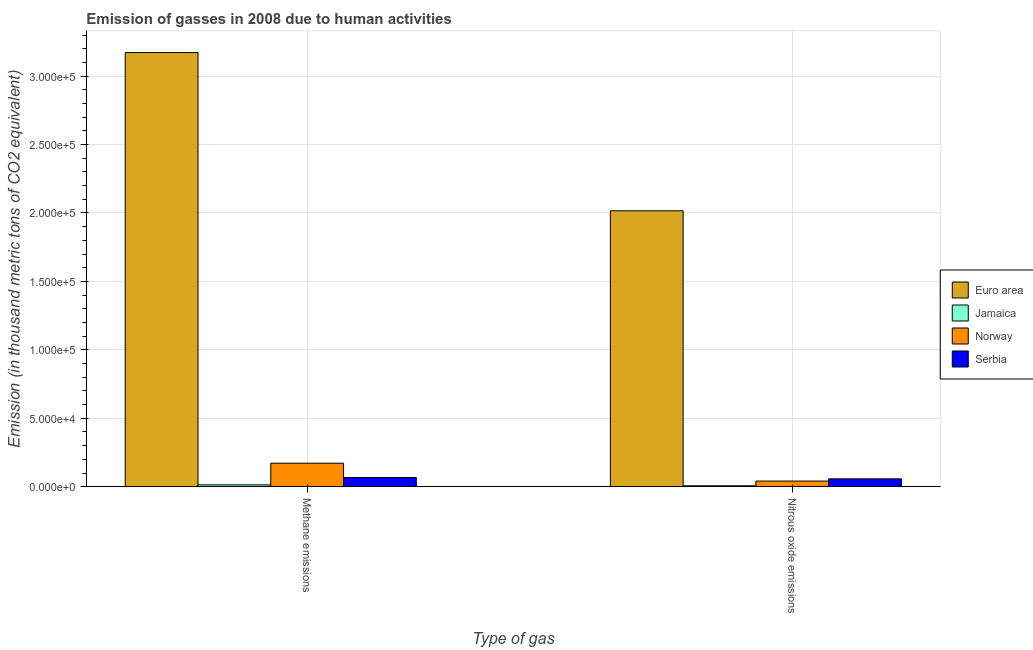Are the number of bars on each tick of the X-axis equal?
Give a very brief answer. Yes. How many bars are there on the 1st tick from the left?
Your answer should be very brief. 4. What is the label of the 2nd group of bars from the left?
Your answer should be very brief. Nitrous oxide emissions. What is the amount of nitrous oxide emissions in Jamaica?
Offer a terse response. 666.6. Across all countries, what is the maximum amount of nitrous oxide emissions?
Your answer should be very brief. 2.02e+05. Across all countries, what is the minimum amount of methane emissions?
Offer a very short reply. 1330.9. In which country was the amount of nitrous oxide emissions maximum?
Your response must be concise. Euro area. In which country was the amount of nitrous oxide emissions minimum?
Your answer should be very brief. Jamaica. What is the total amount of methane emissions in the graph?
Your answer should be compact. 3.42e+05. What is the difference between the amount of methane emissions in Jamaica and that in Serbia?
Your answer should be very brief. -5395.5. What is the difference between the amount of methane emissions in Jamaica and the amount of nitrous oxide emissions in Norway?
Provide a short and direct response. -2771.8. What is the average amount of methane emissions per country?
Offer a very short reply. 8.56e+04. What is the difference between the amount of nitrous oxide emissions and amount of methane emissions in Norway?
Provide a short and direct response. -1.31e+04. In how many countries, is the amount of methane emissions greater than 290000 thousand metric tons?
Ensure brevity in your answer.  1. What is the ratio of the amount of methane emissions in Euro area to that in Jamaica?
Offer a terse response. 238.38. How many bars are there?
Provide a succinct answer. 8. What is the difference between two consecutive major ticks on the Y-axis?
Provide a succinct answer. 5.00e+04. Does the graph contain any zero values?
Your response must be concise. No. Does the graph contain grids?
Make the answer very short. Yes. How are the legend labels stacked?
Your response must be concise. Vertical. What is the title of the graph?
Offer a very short reply. Emission of gasses in 2008 due to human activities. What is the label or title of the X-axis?
Your answer should be very brief. Type of gas. What is the label or title of the Y-axis?
Make the answer very short. Emission (in thousand metric tons of CO2 equivalent). What is the Emission (in thousand metric tons of CO2 equivalent) in Euro area in Methane emissions?
Make the answer very short. 3.17e+05. What is the Emission (in thousand metric tons of CO2 equivalent) in Jamaica in Methane emissions?
Make the answer very short. 1330.9. What is the Emission (in thousand metric tons of CO2 equivalent) of Norway in Methane emissions?
Your answer should be compact. 1.72e+04. What is the Emission (in thousand metric tons of CO2 equivalent) in Serbia in Methane emissions?
Provide a succinct answer. 6726.4. What is the Emission (in thousand metric tons of CO2 equivalent) of Euro area in Nitrous oxide emissions?
Provide a succinct answer. 2.02e+05. What is the Emission (in thousand metric tons of CO2 equivalent) in Jamaica in Nitrous oxide emissions?
Your answer should be very brief. 666.6. What is the Emission (in thousand metric tons of CO2 equivalent) in Norway in Nitrous oxide emissions?
Ensure brevity in your answer.  4102.7. What is the Emission (in thousand metric tons of CO2 equivalent) in Serbia in Nitrous oxide emissions?
Ensure brevity in your answer.  5711.8. Across all Type of gas, what is the maximum Emission (in thousand metric tons of CO2 equivalent) of Euro area?
Keep it short and to the point. 3.17e+05. Across all Type of gas, what is the maximum Emission (in thousand metric tons of CO2 equivalent) of Jamaica?
Keep it short and to the point. 1330.9. Across all Type of gas, what is the maximum Emission (in thousand metric tons of CO2 equivalent) in Norway?
Give a very brief answer. 1.72e+04. Across all Type of gas, what is the maximum Emission (in thousand metric tons of CO2 equivalent) in Serbia?
Offer a terse response. 6726.4. Across all Type of gas, what is the minimum Emission (in thousand metric tons of CO2 equivalent) in Euro area?
Offer a terse response. 2.02e+05. Across all Type of gas, what is the minimum Emission (in thousand metric tons of CO2 equivalent) in Jamaica?
Your response must be concise. 666.6. Across all Type of gas, what is the minimum Emission (in thousand metric tons of CO2 equivalent) in Norway?
Provide a succinct answer. 4102.7. Across all Type of gas, what is the minimum Emission (in thousand metric tons of CO2 equivalent) of Serbia?
Offer a very short reply. 5711.8. What is the total Emission (in thousand metric tons of CO2 equivalent) in Euro area in the graph?
Offer a terse response. 5.19e+05. What is the total Emission (in thousand metric tons of CO2 equivalent) in Jamaica in the graph?
Your answer should be compact. 1997.5. What is the total Emission (in thousand metric tons of CO2 equivalent) of Norway in the graph?
Provide a succinct answer. 2.13e+04. What is the total Emission (in thousand metric tons of CO2 equivalent) of Serbia in the graph?
Offer a terse response. 1.24e+04. What is the difference between the Emission (in thousand metric tons of CO2 equivalent) of Euro area in Methane emissions and that in Nitrous oxide emissions?
Offer a terse response. 1.16e+05. What is the difference between the Emission (in thousand metric tons of CO2 equivalent) in Jamaica in Methane emissions and that in Nitrous oxide emissions?
Your answer should be compact. 664.3. What is the difference between the Emission (in thousand metric tons of CO2 equivalent) in Norway in Methane emissions and that in Nitrous oxide emissions?
Provide a succinct answer. 1.31e+04. What is the difference between the Emission (in thousand metric tons of CO2 equivalent) in Serbia in Methane emissions and that in Nitrous oxide emissions?
Your answer should be very brief. 1014.6. What is the difference between the Emission (in thousand metric tons of CO2 equivalent) in Euro area in Methane emissions and the Emission (in thousand metric tons of CO2 equivalent) in Jamaica in Nitrous oxide emissions?
Offer a very short reply. 3.17e+05. What is the difference between the Emission (in thousand metric tons of CO2 equivalent) of Euro area in Methane emissions and the Emission (in thousand metric tons of CO2 equivalent) of Norway in Nitrous oxide emissions?
Ensure brevity in your answer.  3.13e+05. What is the difference between the Emission (in thousand metric tons of CO2 equivalent) of Euro area in Methane emissions and the Emission (in thousand metric tons of CO2 equivalent) of Serbia in Nitrous oxide emissions?
Make the answer very short. 3.12e+05. What is the difference between the Emission (in thousand metric tons of CO2 equivalent) in Jamaica in Methane emissions and the Emission (in thousand metric tons of CO2 equivalent) in Norway in Nitrous oxide emissions?
Give a very brief answer. -2771.8. What is the difference between the Emission (in thousand metric tons of CO2 equivalent) in Jamaica in Methane emissions and the Emission (in thousand metric tons of CO2 equivalent) in Serbia in Nitrous oxide emissions?
Keep it short and to the point. -4380.9. What is the difference between the Emission (in thousand metric tons of CO2 equivalent) in Norway in Methane emissions and the Emission (in thousand metric tons of CO2 equivalent) in Serbia in Nitrous oxide emissions?
Provide a short and direct response. 1.15e+04. What is the average Emission (in thousand metric tons of CO2 equivalent) in Euro area per Type of gas?
Your answer should be compact. 2.59e+05. What is the average Emission (in thousand metric tons of CO2 equivalent) of Jamaica per Type of gas?
Give a very brief answer. 998.75. What is the average Emission (in thousand metric tons of CO2 equivalent) of Norway per Type of gas?
Your response must be concise. 1.06e+04. What is the average Emission (in thousand metric tons of CO2 equivalent) in Serbia per Type of gas?
Provide a short and direct response. 6219.1. What is the difference between the Emission (in thousand metric tons of CO2 equivalent) of Euro area and Emission (in thousand metric tons of CO2 equivalent) of Jamaica in Methane emissions?
Ensure brevity in your answer.  3.16e+05. What is the difference between the Emission (in thousand metric tons of CO2 equivalent) in Euro area and Emission (in thousand metric tons of CO2 equivalent) in Norway in Methane emissions?
Offer a very short reply. 3.00e+05. What is the difference between the Emission (in thousand metric tons of CO2 equivalent) of Euro area and Emission (in thousand metric tons of CO2 equivalent) of Serbia in Methane emissions?
Ensure brevity in your answer.  3.11e+05. What is the difference between the Emission (in thousand metric tons of CO2 equivalent) in Jamaica and Emission (in thousand metric tons of CO2 equivalent) in Norway in Methane emissions?
Your answer should be compact. -1.58e+04. What is the difference between the Emission (in thousand metric tons of CO2 equivalent) in Jamaica and Emission (in thousand metric tons of CO2 equivalent) in Serbia in Methane emissions?
Your answer should be compact. -5395.5. What is the difference between the Emission (in thousand metric tons of CO2 equivalent) in Norway and Emission (in thousand metric tons of CO2 equivalent) in Serbia in Methane emissions?
Provide a short and direct response. 1.04e+04. What is the difference between the Emission (in thousand metric tons of CO2 equivalent) in Euro area and Emission (in thousand metric tons of CO2 equivalent) in Jamaica in Nitrous oxide emissions?
Your response must be concise. 2.01e+05. What is the difference between the Emission (in thousand metric tons of CO2 equivalent) of Euro area and Emission (in thousand metric tons of CO2 equivalent) of Norway in Nitrous oxide emissions?
Your answer should be very brief. 1.98e+05. What is the difference between the Emission (in thousand metric tons of CO2 equivalent) in Euro area and Emission (in thousand metric tons of CO2 equivalent) in Serbia in Nitrous oxide emissions?
Give a very brief answer. 1.96e+05. What is the difference between the Emission (in thousand metric tons of CO2 equivalent) of Jamaica and Emission (in thousand metric tons of CO2 equivalent) of Norway in Nitrous oxide emissions?
Ensure brevity in your answer.  -3436.1. What is the difference between the Emission (in thousand metric tons of CO2 equivalent) of Jamaica and Emission (in thousand metric tons of CO2 equivalent) of Serbia in Nitrous oxide emissions?
Ensure brevity in your answer.  -5045.2. What is the difference between the Emission (in thousand metric tons of CO2 equivalent) in Norway and Emission (in thousand metric tons of CO2 equivalent) in Serbia in Nitrous oxide emissions?
Keep it short and to the point. -1609.1. What is the ratio of the Emission (in thousand metric tons of CO2 equivalent) of Euro area in Methane emissions to that in Nitrous oxide emissions?
Your answer should be compact. 1.57. What is the ratio of the Emission (in thousand metric tons of CO2 equivalent) of Jamaica in Methane emissions to that in Nitrous oxide emissions?
Keep it short and to the point. 2. What is the ratio of the Emission (in thousand metric tons of CO2 equivalent) of Norway in Methane emissions to that in Nitrous oxide emissions?
Offer a very short reply. 4.19. What is the ratio of the Emission (in thousand metric tons of CO2 equivalent) in Serbia in Methane emissions to that in Nitrous oxide emissions?
Keep it short and to the point. 1.18. What is the difference between the highest and the second highest Emission (in thousand metric tons of CO2 equivalent) of Euro area?
Keep it short and to the point. 1.16e+05. What is the difference between the highest and the second highest Emission (in thousand metric tons of CO2 equivalent) in Jamaica?
Offer a very short reply. 664.3. What is the difference between the highest and the second highest Emission (in thousand metric tons of CO2 equivalent) in Norway?
Ensure brevity in your answer.  1.31e+04. What is the difference between the highest and the second highest Emission (in thousand metric tons of CO2 equivalent) in Serbia?
Your answer should be compact. 1014.6. What is the difference between the highest and the lowest Emission (in thousand metric tons of CO2 equivalent) in Euro area?
Your answer should be very brief. 1.16e+05. What is the difference between the highest and the lowest Emission (in thousand metric tons of CO2 equivalent) of Jamaica?
Offer a very short reply. 664.3. What is the difference between the highest and the lowest Emission (in thousand metric tons of CO2 equivalent) in Norway?
Provide a succinct answer. 1.31e+04. What is the difference between the highest and the lowest Emission (in thousand metric tons of CO2 equivalent) in Serbia?
Provide a short and direct response. 1014.6. 